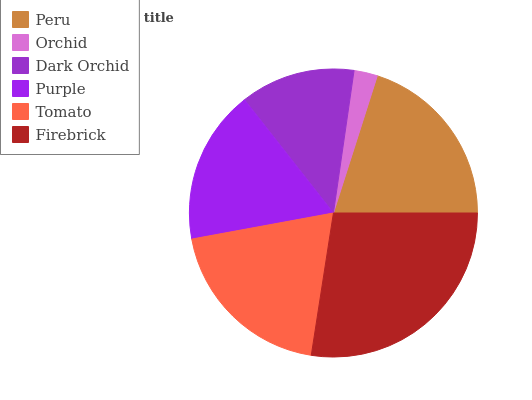Is Orchid the minimum?
Answer yes or no. Yes. Is Firebrick the maximum?
Answer yes or no. Yes. Is Dark Orchid the minimum?
Answer yes or no. No. Is Dark Orchid the maximum?
Answer yes or no. No. Is Dark Orchid greater than Orchid?
Answer yes or no. Yes. Is Orchid less than Dark Orchid?
Answer yes or no. Yes. Is Orchid greater than Dark Orchid?
Answer yes or no. No. Is Dark Orchid less than Orchid?
Answer yes or no. No. Is Tomato the high median?
Answer yes or no. Yes. Is Purple the low median?
Answer yes or no. Yes. Is Purple the high median?
Answer yes or no. No. Is Firebrick the low median?
Answer yes or no. No. 